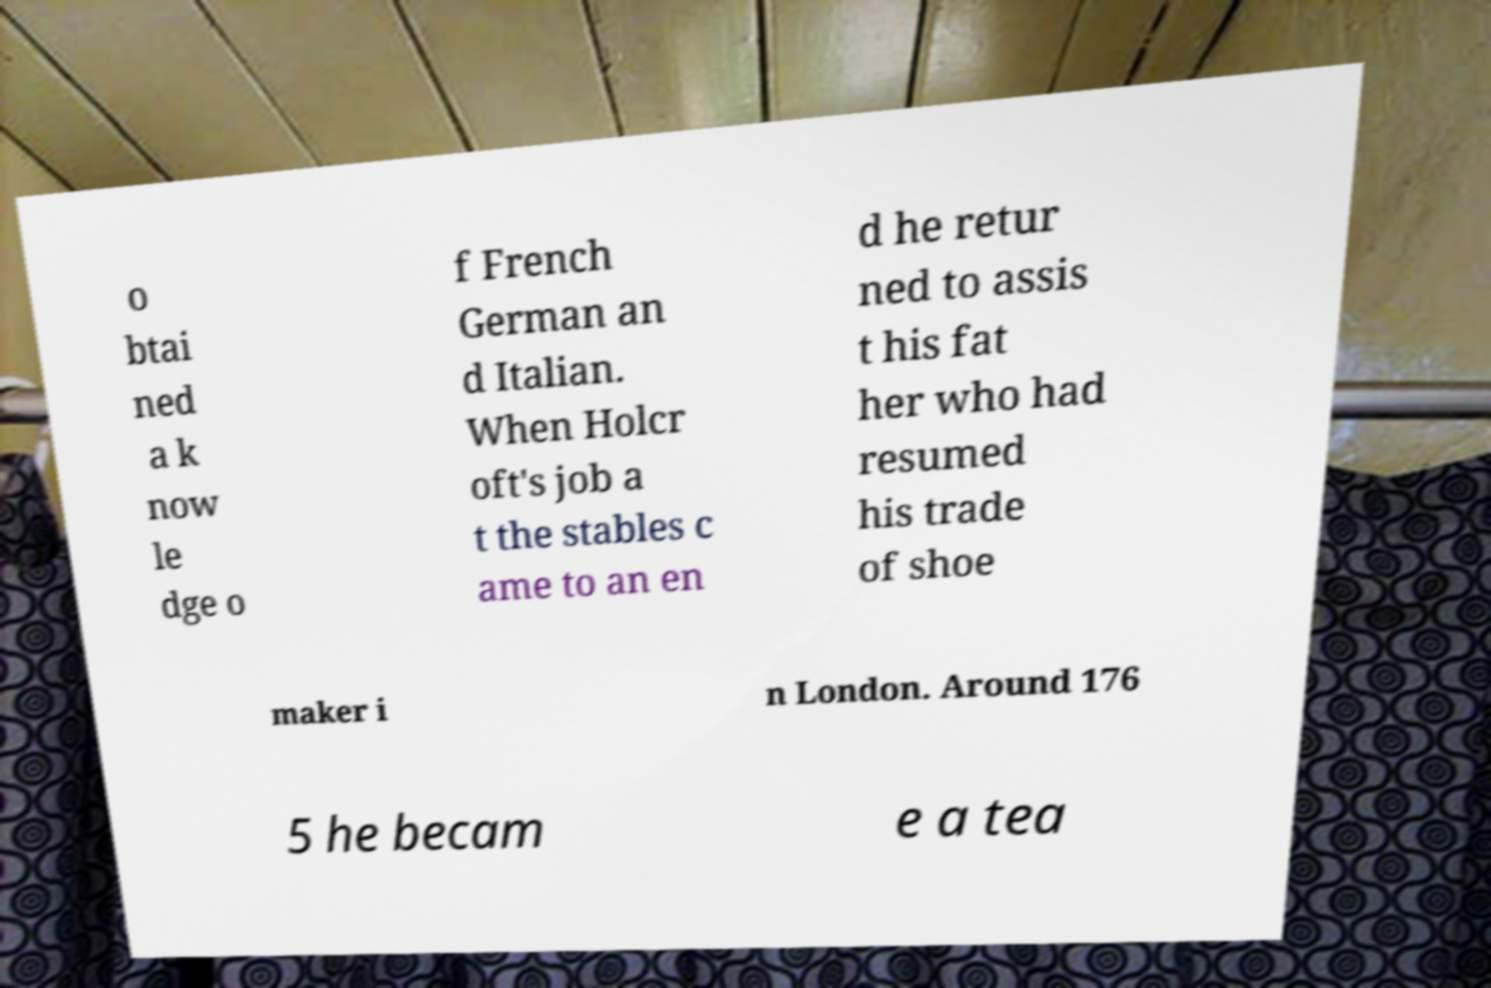Can you read and provide the text displayed in the image?This photo seems to have some interesting text. Can you extract and type it out for me? o btai ned a k now le dge o f French German an d Italian. When Holcr oft's job a t the stables c ame to an en d he retur ned to assis t his fat her who had resumed his trade of shoe maker i n London. Around 176 5 he becam e a tea 